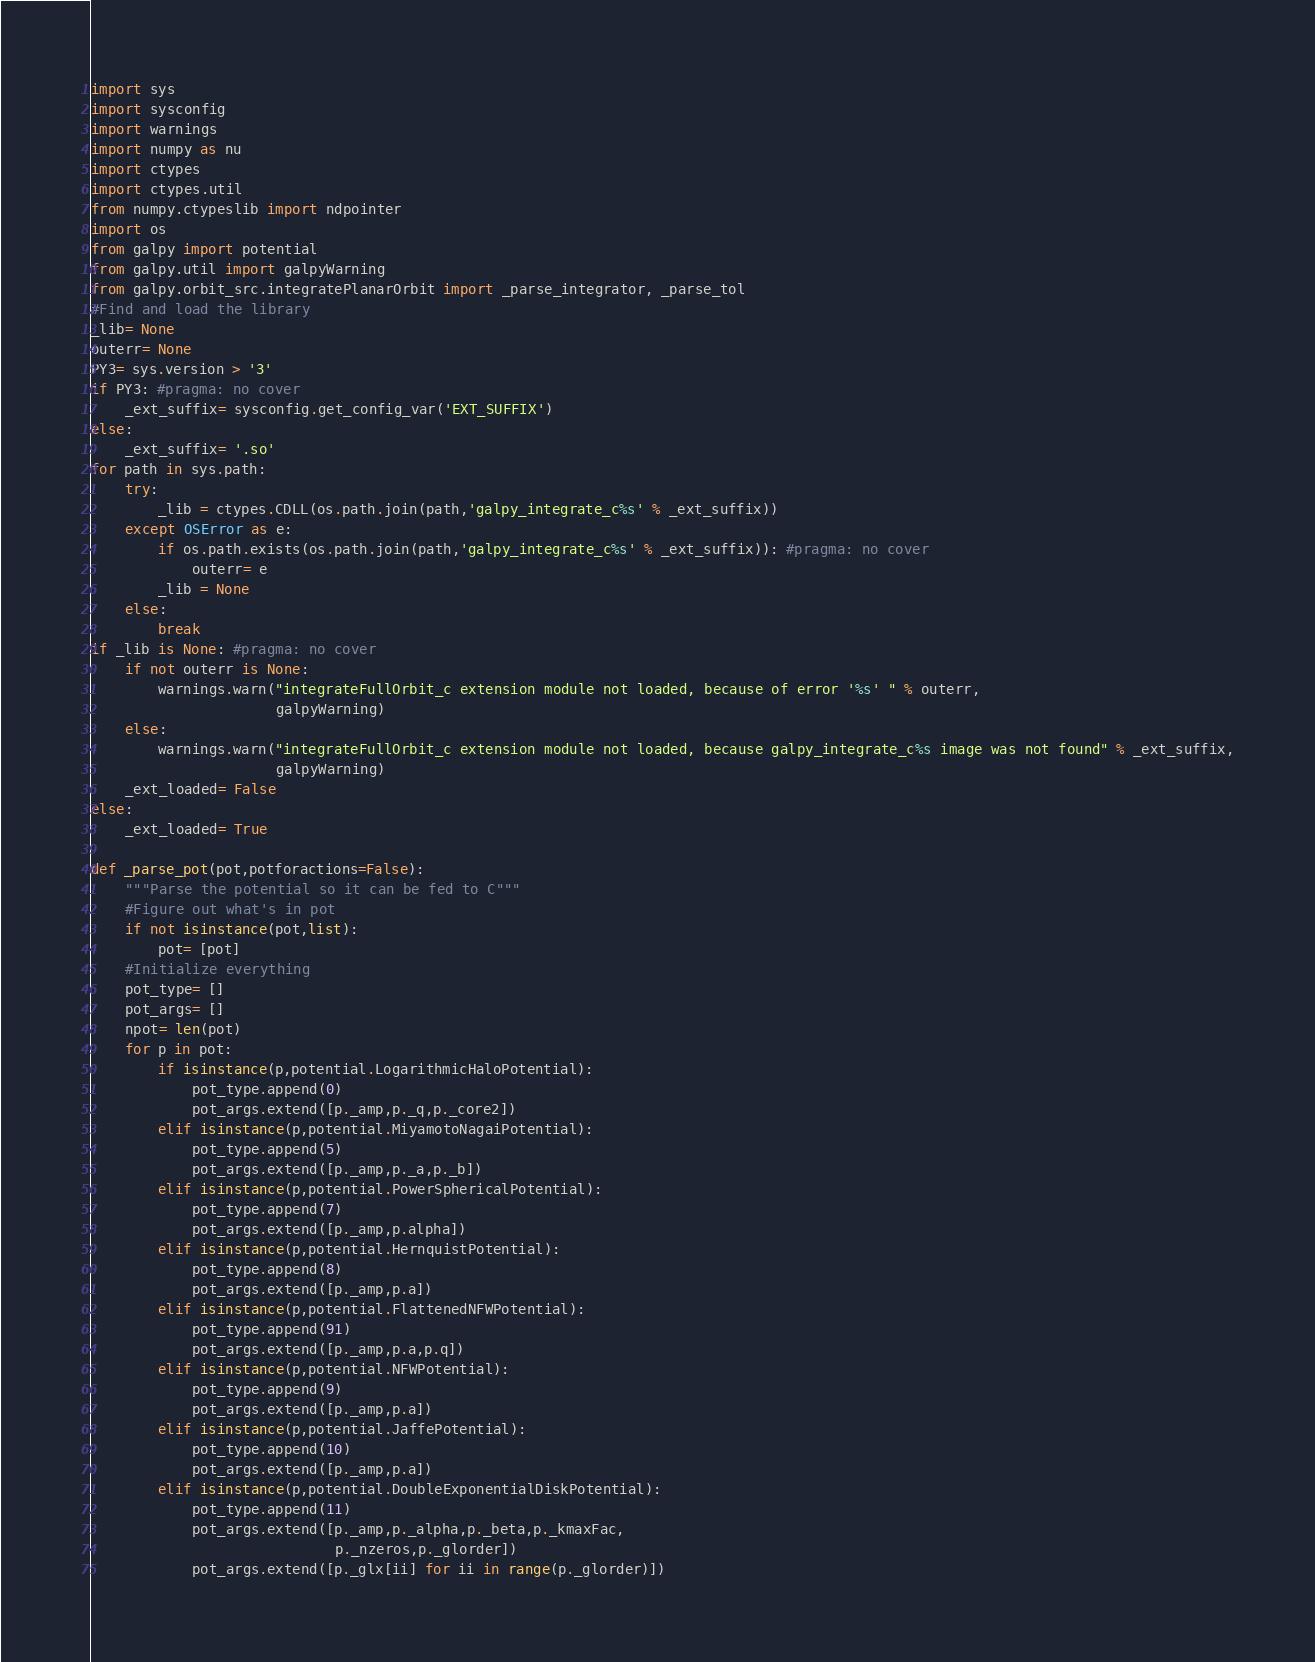Convert code to text. <code><loc_0><loc_0><loc_500><loc_500><_Python_>import sys
import sysconfig
import warnings
import numpy as nu
import ctypes
import ctypes.util
from numpy.ctypeslib import ndpointer
import os
from galpy import potential
from galpy.util import galpyWarning
from galpy.orbit_src.integratePlanarOrbit import _parse_integrator, _parse_tol
#Find and load the library
_lib= None
outerr= None
PY3= sys.version > '3'
if PY3: #pragma: no cover
    _ext_suffix= sysconfig.get_config_var('EXT_SUFFIX')
else:
    _ext_suffix= '.so'
for path in sys.path:
    try:
        _lib = ctypes.CDLL(os.path.join(path,'galpy_integrate_c%s' % _ext_suffix))
    except OSError as e:
        if os.path.exists(os.path.join(path,'galpy_integrate_c%s' % _ext_suffix)): #pragma: no cover
            outerr= e
        _lib = None
    else:
        break
if _lib is None: #pragma: no cover
    if not outerr is None:
        warnings.warn("integrateFullOrbit_c extension module not loaded, because of error '%s' " % outerr,
                      galpyWarning)
    else:
        warnings.warn("integrateFullOrbit_c extension module not loaded, because galpy_integrate_c%s image was not found" % _ext_suffix,
                      galpyWarning)
    _ext_loaded= False
else:
    _ext_loaded= True

def _parse_pot(pot,potforactions=False):
    """Parse the potential so it can be fed to C"""
    #Figure out what's in pot
    if not isinstance(pot,list):
        pot= [pot]
    #Initialize everything
    pot_type= []
    pot_args= []
    npot= len(pot)
    for p in pot:
        if isinstance(p,potential.LogarithmicHaloPotential):
            pot_type.append(0)
            pot_args.extend([p._amp,p._q,p._core2])
        elif isinstance(p,potential.MiyamotoNagaiPotential):
            pot_type.append(5)
            pot_args.extend([p._amp,p._a,p._b])
        elif isinstance(p,potential.PowerSphericalPotential):
            pot_type.append(7)
            pot_args.extend([p._amp,p.alpha])
        elif isinstance(p,potential.HernquistPotential):
            pot_type.append(8)
            pot_args.extend([p._amp,p.a])
        elif isinstance(p,potential.FlattenedNFWPotential):
            pot_type.append(91)
            pot_args.extend([p._amp,p.a,p.q])
        elif isinstance(p,potential.NFWPotential):
            pot_type.append(9)
            pot_args.extend([p._amp,p.a])
        elif isinstance(p,potential.JaffePotential):
            pot_type.append(10)
            pot_args.extend([p._amp,p.a])
        elif isinstance(p,potential.DoubleExponentialDiskPotential):
            pot_type.append(11)
            pot_args.extend([p._amp,p._alpha,p._beta,p._kmaxFac,
                             p._nzeros,p._glorder])
            pot_args.extend([p._glx[ii] for ii in range(p._glorder)])</code> 